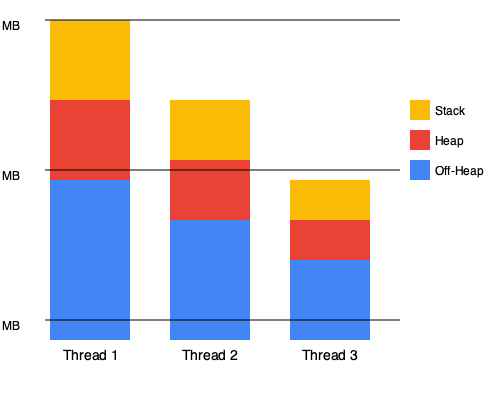Given the stacked bar chart representing memory allocation across three threads in a multi-threaded Scala application, what is the total memory usage of Thread 2, and what percentage of this usage is allocated to the heap? To solve this problem, we need to follow these steps:

1. Identify Thread 2's bar in the chart (the middle bar).
2. Calculate the total height of Thread 2's bar:
   - The bar consists of three sections: stack (yellow), heap (red), and off-heap (blue).
   - Each small square represents 20 MB (80 MB / 4 squares in Thread 1).
   - Thread 2's bar has 12 small squares in total.
   - Total memory = 12 * 20 MB = 240 MB

3. Calculate the heap (red) section of Thread 2:
   - The red section consists of 6 small squares.
   - Heap memory = 6 * 20 MB = 120 MB

4. Calculate the percentage of heap memory:
   - Percentage = (Heap memory / Total memory) * 100
   - Percentage = (120 MB / 240 MB) * 100 = 50%

Therefore, the total memory usage of Thread 2 is 240 MB, and 50% of this usage is allocated to the heap.
Answer: 240 MB total, 50% heap 